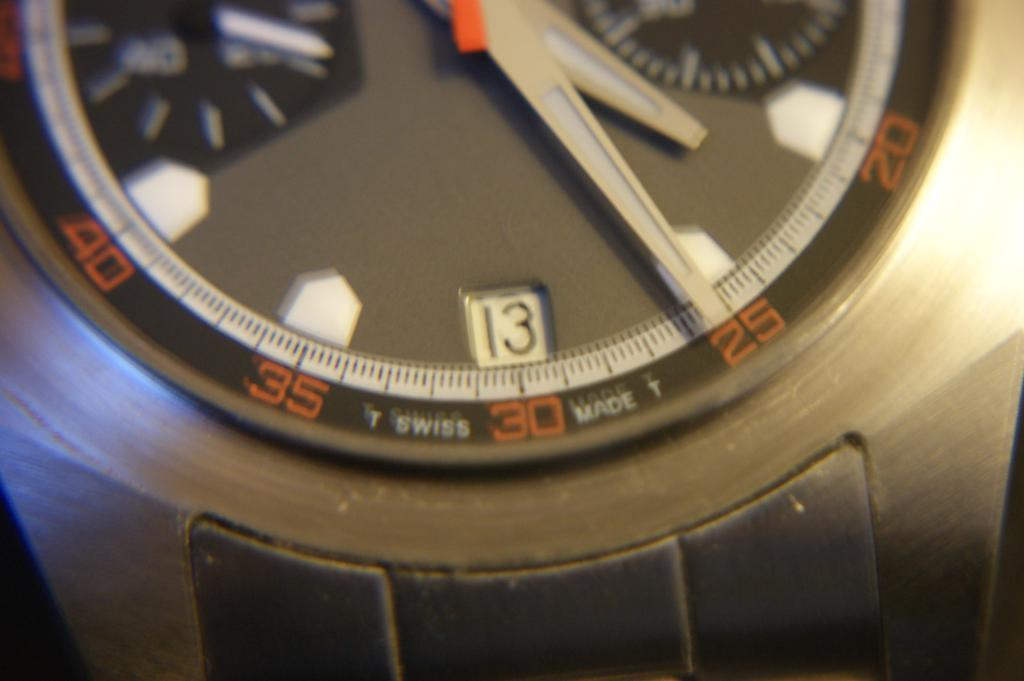<image>
Share a concise interpretation of the image provided. A watch that was made by T Swiss. 